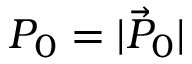Convert formula to latex. <formula><loc_0><loc_0><loc_500><loc_500>P _ { 0 } = | \vec { P } _ { 0 } |</formula> 